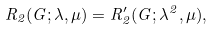Convert formula to latex. <formula><loc_0><loc_0><loc_500><loc_500>R _ { 2 } ( G ; \lambda , \mu ) = R ^ { \prime } _ { 2 } ( G ; \lambda ^ { 2 } , \mu ) ,</formula> 